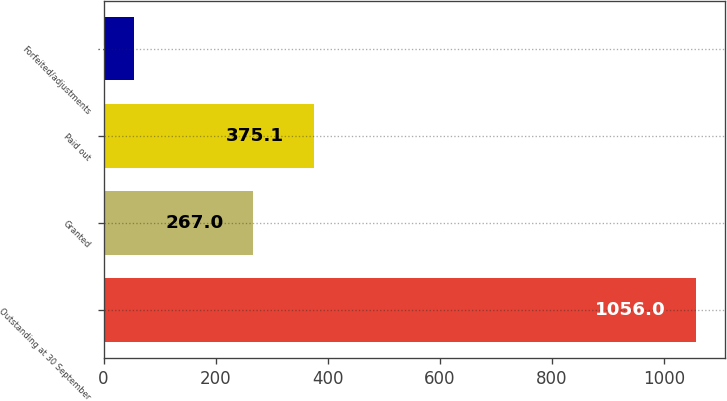<chart> <loc_0><loc_0><loc_500><loc_500><bar_chart><fcel>Outstanding at 30 September<fcel>Granted<fcel>Paid out<fcel>Forfeited/adjustments<nl><fcel>1056<fcel>267<fcel>375.1<fcel>55<nl></chart> 